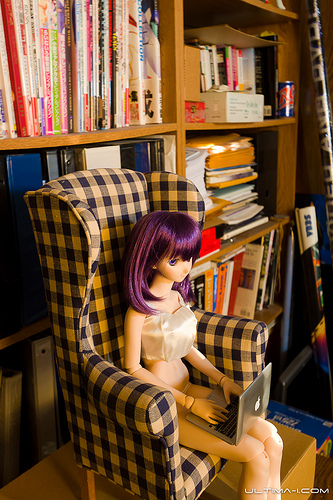<image>
Can you confirm if the book is on the sofa? No. The book is not positioned on the sofa. They may be near each other, but the book is not supported by or resting on top of the sofa. 